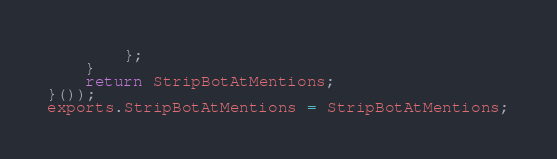<code> <loc_0><loc_0><loc_500><loc_500><_JavaScript_>        };
    }
    return StripBotAtMentions;
}());
exports.StripBotAtMentions = StripBotAtMentions;
</code> 